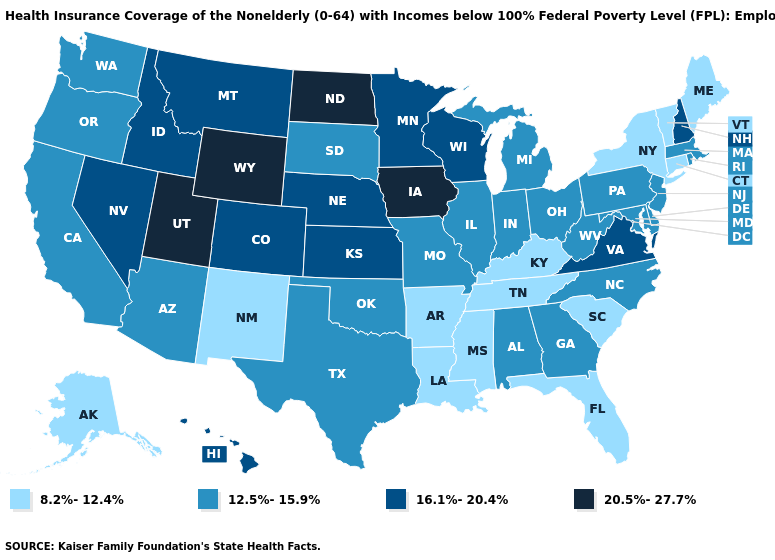Name the states that have a value in the range 8.2%-12.4%?
Quick response, please. Alaska, Arkansas, Connecticut, Florida, Kentucky, Louisiana, Maine, Mississippi, New Mexico, New York, South Carolina, Tennessee, Vermont. Name the states that have a value in the range 20.5%-27.7%?
Be succinct. Iowa, North Dakota, Utah, Wyoming. Does Arizona have a lower value than Iowa?
Give a very brief answer. Yes. Does Kentucky have a lower value than Maryland?
Concise answer only. Yes. What is the lowest value in the USA?
Answer briefly. 8.2%-12.4%. What is the lowest value in the USA?
Be succinct. 8.2%-12.4%. Among the states that border Washington , which have the highest value?
Be succinct. Idaho. What is the value of New Hampshire?
Give a very brief answer. 16.1%-20.4%. What is the value of Texas?
Keep it brief. 12.5%-15.9%. Does the first symbol in the legend represent the smallest category?
Answer briefly. Yes. Which states have the highest value in the USA?
Write a very short answer. Iowa, North Dakota, Utah, Wyoming. Name the states that have a value in the range 12.5%-15.9%?
Concise answer only. Alabama, Arizona, California, Delaware, Georgia, Illinois, Indiana, Maryland, Massachusetts, Michigan, Missouri, New Jersey, North Carolina, Ohio, Oklahoma, Oregon, Pennsylvania, Rhode Island, South Dakota, Texas, Washington, West Virginia. Does Iowa have the highest value in the USA?
Keep it brief. Yes. Does the first symbol in the legend represent the smallest category?
Write a very short answer. Yes. What is the value of Alaska?
Write a very short answer. 8.2%-12.4%. 